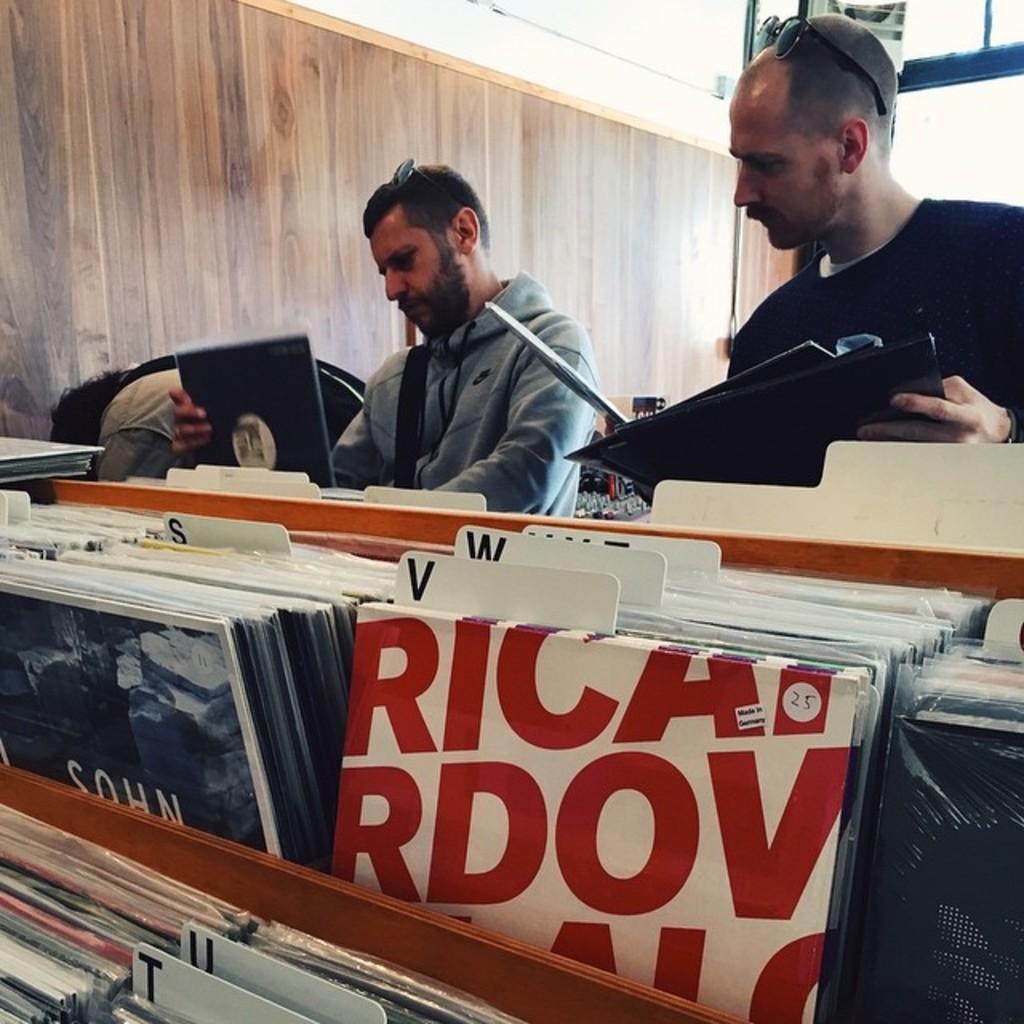How would you summarize this image in a sentence or two? In the center of the image two mans are standing and holding book. At the bottom of the image books are there. At the top of the image wall is present. 